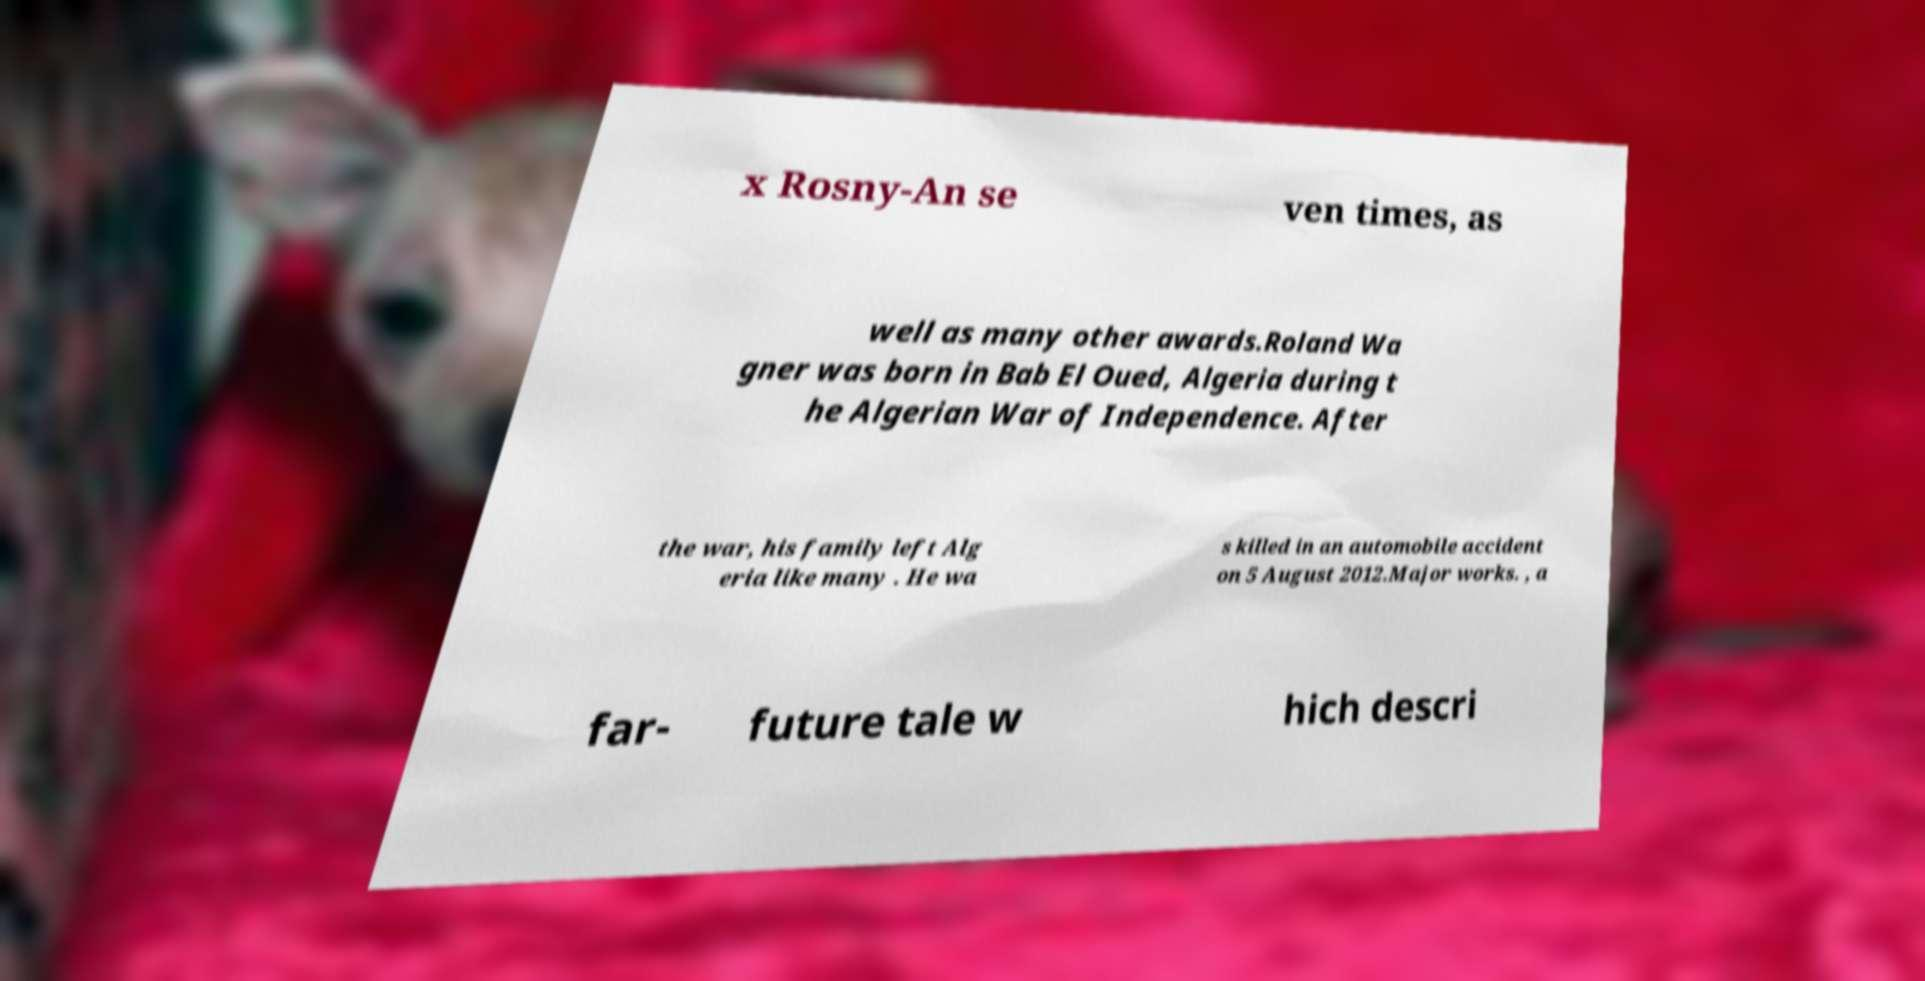Could you extract and type out the text from this image? x Rosny-An se ven times, as well as many other awards.Roland Wa gner was born in Bab El Oued, Algeria during t he Algerian War of Independence. After the war, his family left Alg eria like many . He wa s killed in an automobile accident on 5 August 2012.Major works. , a far- future tale w hich descri 